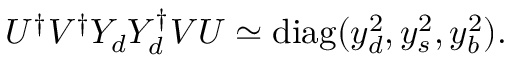Convert formula to latex. <formula><loc_0><loc_0><loc_500><loc_500>U ^ { \dagger } V ^ { \dagger } Y _ { d } Y _ { d } ^ { \dagger } V U \simeq d i a g ( y _ { d } ^ { 2 } , y _ { s } ^ { 2 } , y _ { b } ^ { 2 } ) .</formula> 